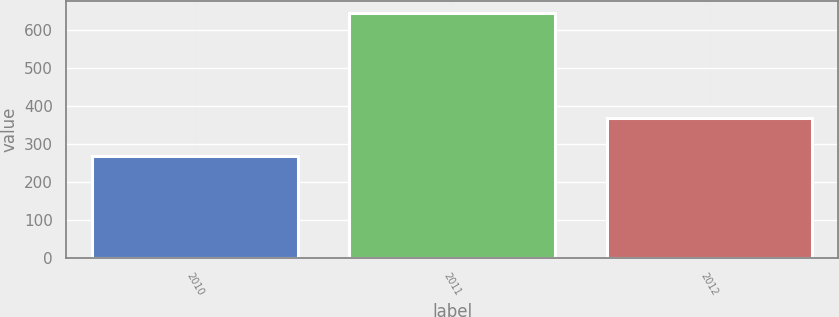Convert chart. <chart><loc_0><loc_0><loc_500><loc_500><bar_chart><fcel>2010<fcel>2011<fcel>2012<nl><fcel>268.2<fcel>643.2<fcel>367.4<nl></chart> 